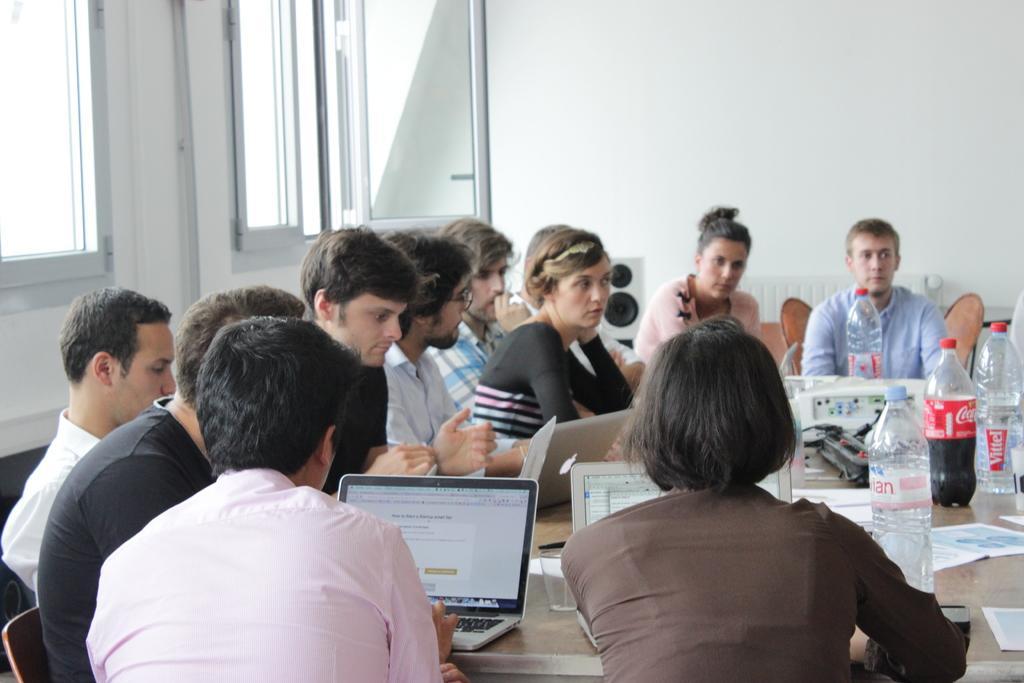Can you describe this image briefly? In this image we can see a group of people sitting on a chair. These three people are working on a laptop. This is a wooden table where laptops and bottles are kept on it. 